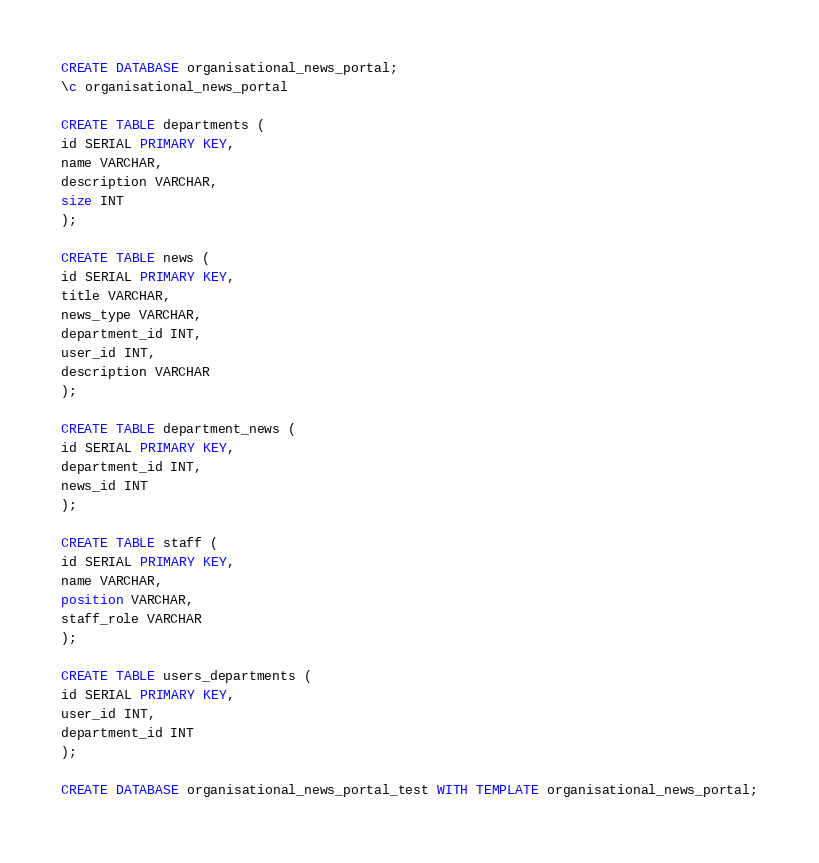<code> <loc_0><loc_0><loc_500><loc_500><_SQL_>CREATE DATABASE organisational_news_portal;
\c organisational_news_portal

CREATE TABLE departments (
id SERIAL PRIMARY KEY,
name VARCHAR,
description VARCHAR,
size INT
);

CREATE TABLE news (
id SERIAL PRIMARY KEY,
title VARCHAR,
news_type VARCHAR,
department_id INT,
user_id INT,
description VARCHAR
);

CREATE TABLE department_news (
id SERIAL PRIMARY KEY,
department_id INT,
news_id INT
);

CREATE TABLE staff (
id SERIAL PRIMARY KEY,
name VARCHAR,
position VARCHAR,
staff_role VARCHAR
);

CREATE TABLE users_departments (
id SERIAL PRIMARY KEY,
user_id INT,
department_id INT
);

CREATE DATABASE organisational_news_portal_test WITH TEMPLATE organisational_news_portal;</code> 